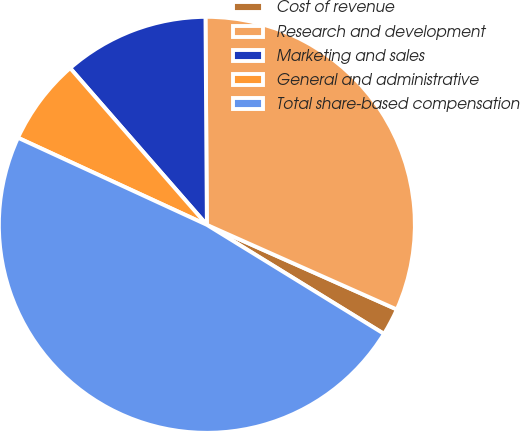<chart> <loc_0><loc_0><loc_500><loc_500><pie_chart><fcel>Cost of revenue<fcel>Research and development<fcel>Marketing and sales<fcel>General and administrative<fcel>Total share-based compensation<nl><fcel>2.11%<fcel>31.78%<fcel>11.31%<fcel>6.71%<fcel>48.1%<nl></chart> 